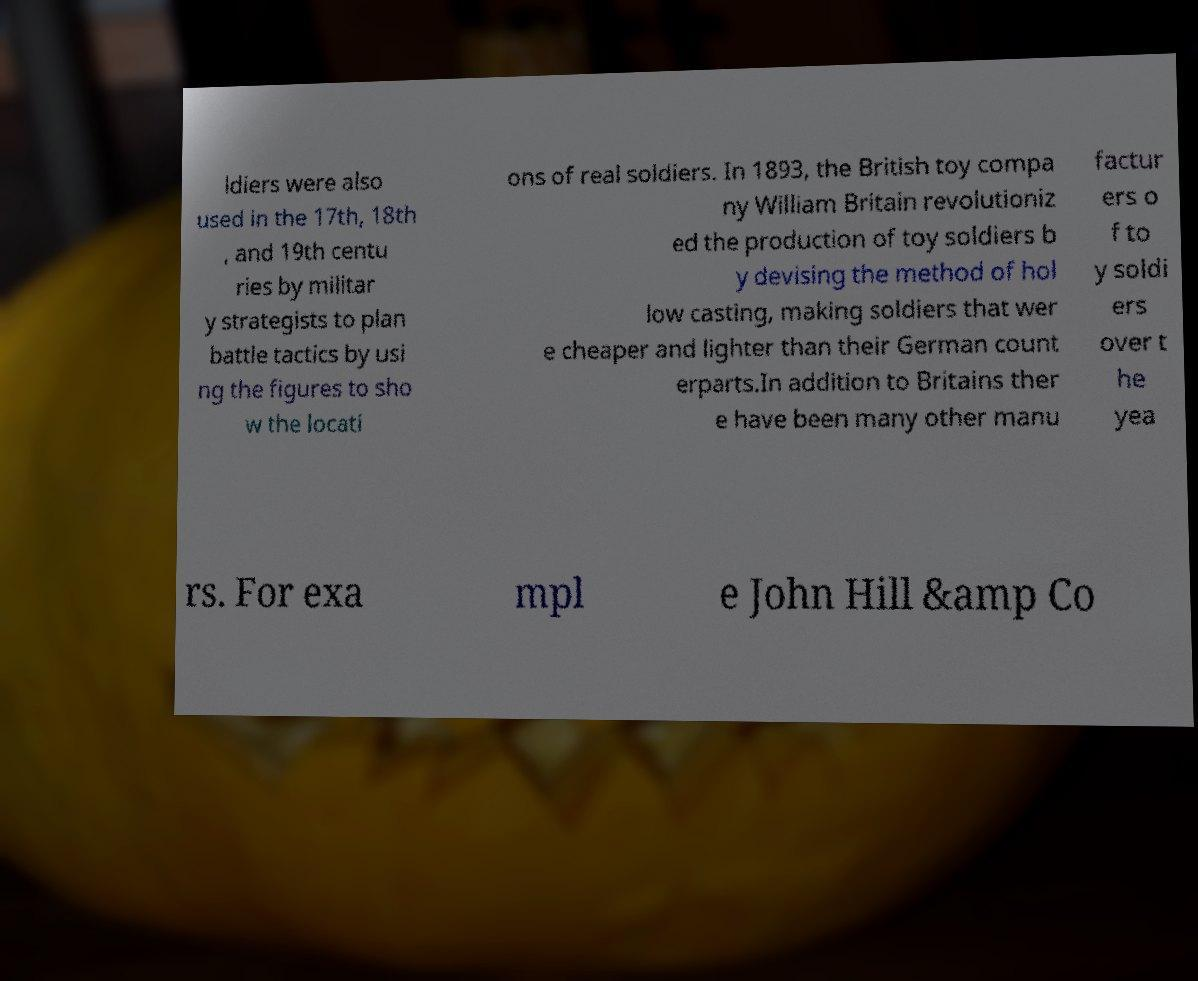Can you accurately transcribe the text from the provided image for me? ldiers were also used in the 17th, 18th , and 19th centu ries by militar y strategists to plan battle tactics by usi ng the figures to sho w the locati ons of real soldiers. In 1893, the British toy compa ny William Britain revolutioniz ed the production of toy soldiers b y devising the method of hol low casting, making soldiers that wer e cheaper and lighter than their German count erparts.In addition to Britains ther e have been many other manu factur ers o f to y soldi ers over t he yea rs. For exa mpl e John Hill &amp Co 